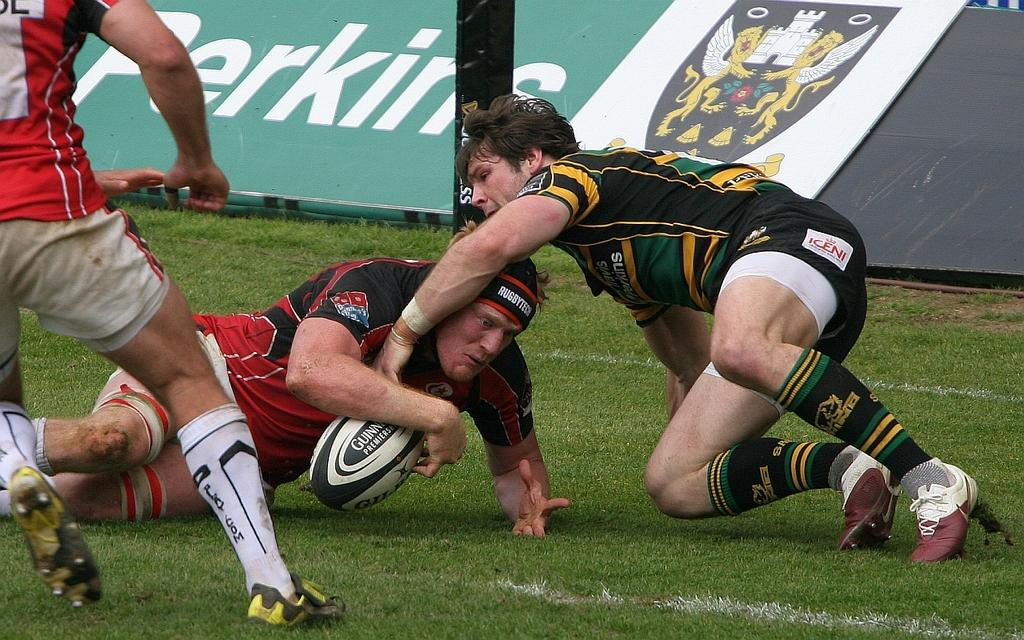Who or what is present in the image? There are people in the image. Where are the people located? The people are on the ground. What are the people doing in the image? The people are playing with a rugby ball. What type of sweater is the cook wearing in the image? There is no cook or sweater present in the image; it features people playing with a rugby ball on the ground. 